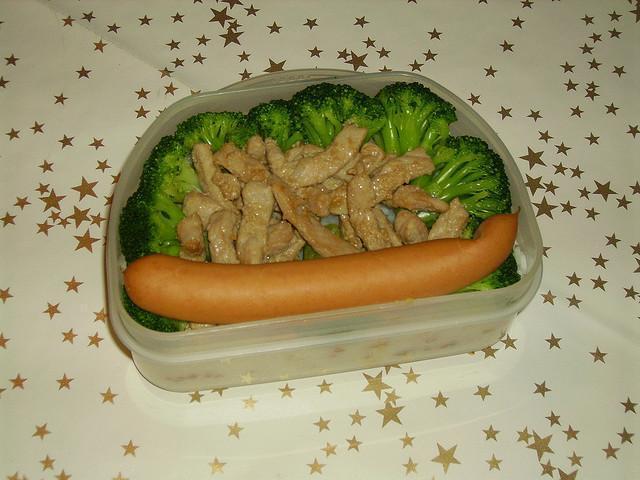How many broccolis are there?
Give a very brief answer. 5. How many people are wearing a hat in the picture?
Give a very brief answer. 0. 